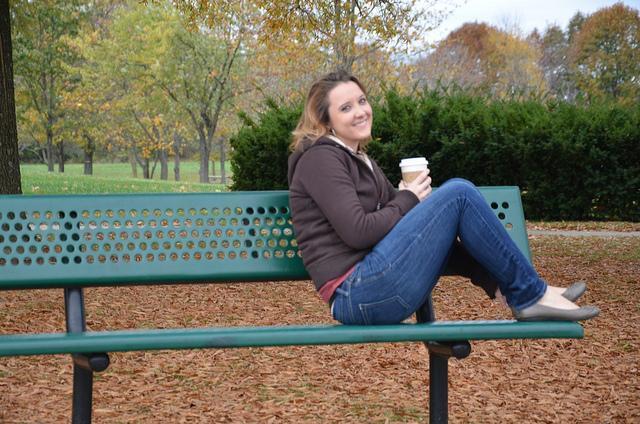How many people are visible?
Give a very brief answer. 1. 